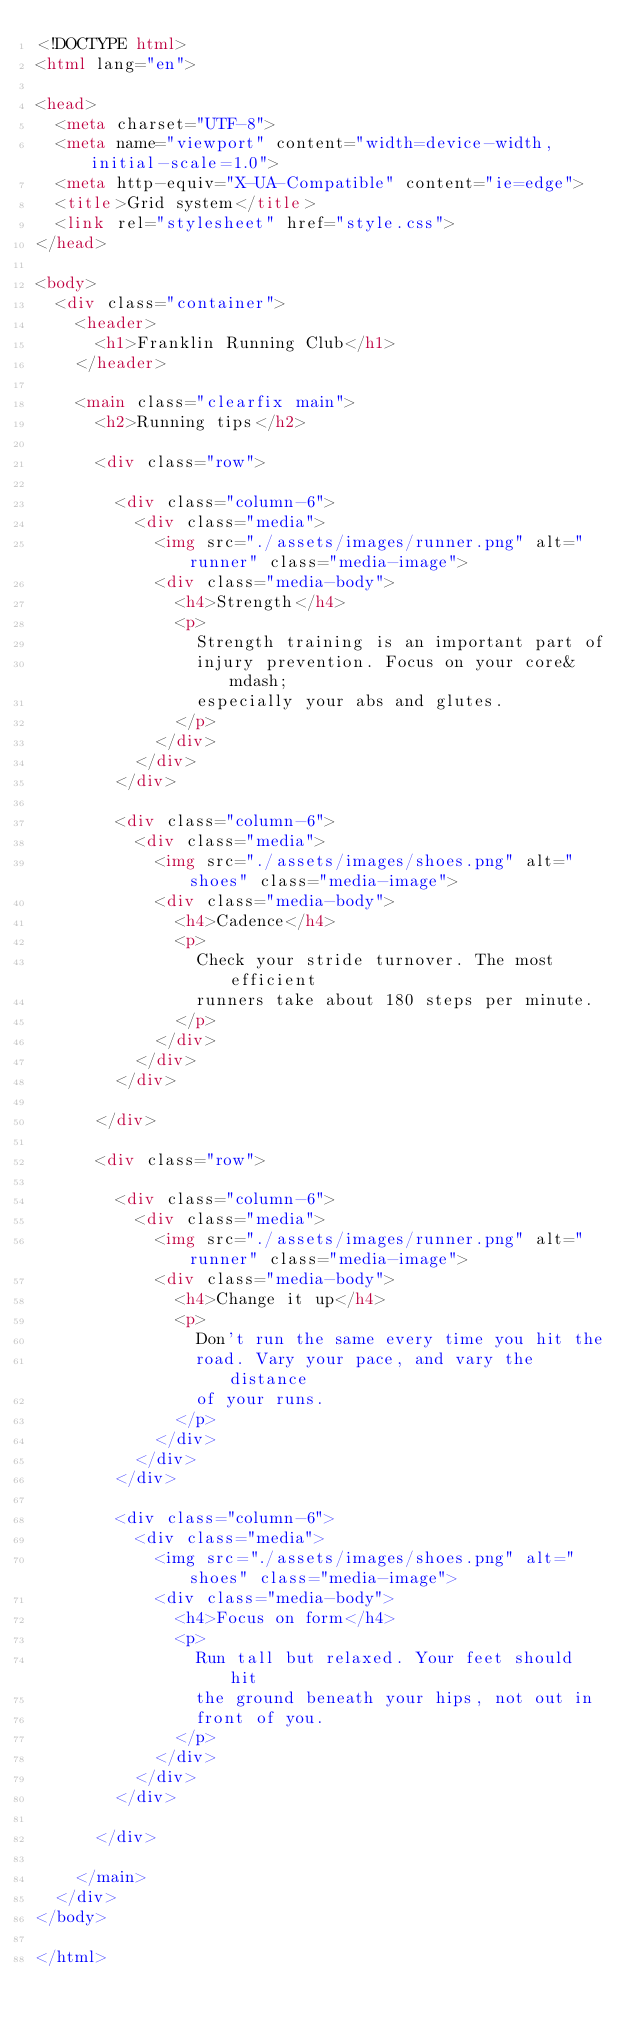<code> <loc_0><loc_0><loc_500><loc_500><_HTML_><!DOCTYPE html>
<html lang="en">

<head>
  <meta charset="UTF-8">
  <meta name="viewport" content="width=device-width, initial-scale=1.0">
  <meta http-equiv="X-UA-Compatible" content="ie=edge">
  <title>Grid system</title>
  <link rel="stylesheet" href="style.css">
</head>

<body>
  <div class="container">
    <header>
      <h1>Franklin Running Club</h1>
    </header>

    <main class="clearfix main">
      <h2>Running tips</h2>

      <div class="row">

        <div class="column-6">
          <div class="media">
            <img src="./assets/images/runner.png" alt="runner" class="media-image">
            <div class="media-body">
              <h4>Strength</h4>
              <p>
                Strength training is an important part of
                injury prevention. Focus on your core&mdash;
                especially your abs and glutes.
              </p>
            </div>
          </div>
        </div>

        <div class="column-6">
          <div class="media">
            <img src="./assets/images/shoes.png" alt="shoes" class="media-image">
            <div class="media-body">
              <h4>Cadence</h4>
              <p>
                Check your stride turnover. The most efficient
                runners take about 180 steps per minute.
              </p>
            </div>
          </div>
        </div>

      </div>

      <div class="row">

        <div class="column-6">
          <div class="media">
            <img src="./assets/images/runner.png" alt="runner" class="media-image">
            <div class="media-body">
              <h4>Change it up</h4>
              <p>
                Don't run the same every time you hit the
                road. Vary your pace, and vary the distance
                of your runs.
              </p>
            </div>
          </div>
        </div>

        <div class="column-6">
          <div class="media">
            <img src="./assets/images/shoes.png" alt="shoes" class="media-image">
            <div class="media-body">
              <h4>Focus on form</h4>
              <p>
                Run tall but relaxed. Your feet should hit
                the ground beneath your hips, not out in
                front of you.
              </p>
            </div>
          </div>
        </div>

      </div>

    </main>
  </div>
</body>

</html></code> 